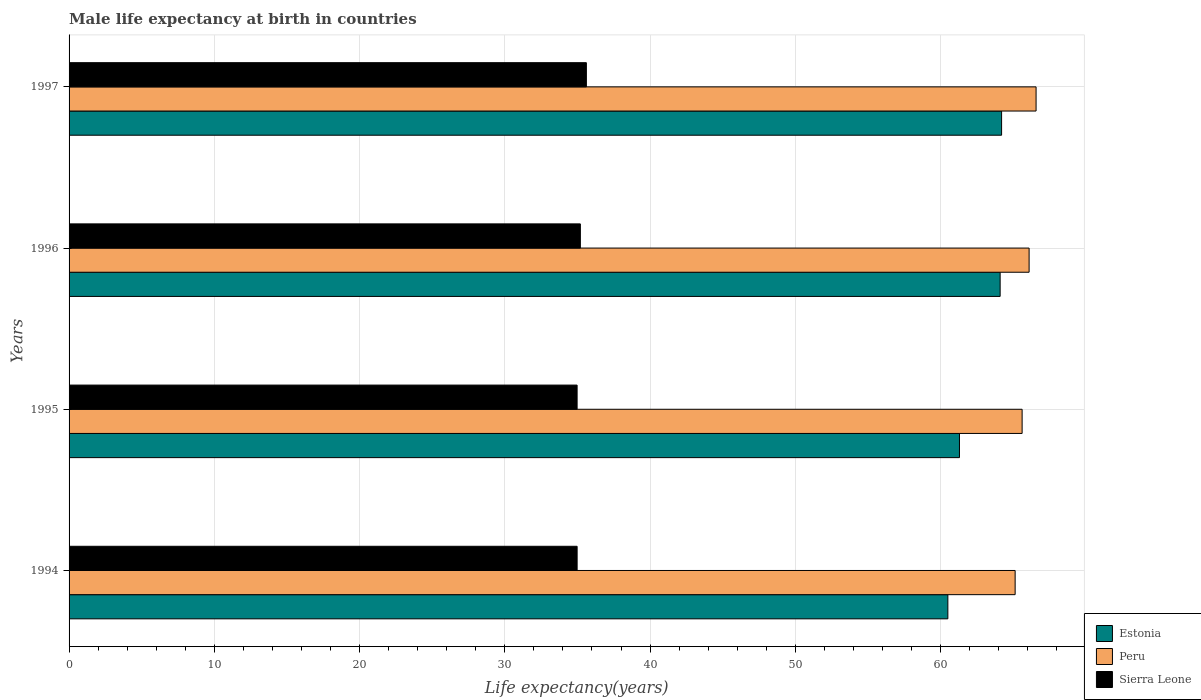How many groups of bars are there?
Your response must be concise. 4. How many bars are there on the 1st tick from the top?
Offer a very short reply. 3. How many bars are there on the 1st tick from the bottom?
Provide a succinct answer. 3. What is the label of the 4th group of bars from the top?
Your answer should be very brief. 1994. In how many cases, is the number of bars for a given year not equal to the number of legend labels?
Provide a succinct answer. 0. What is the male life expectancy at birth in Sierra Leone in 1995?
Your answer should be compact. 34.98. Across all years, what is the maximum male life expectancy at birth in Sierra Leone?
Provide a succinct answer. 35.61. Across all years, what is the minimum male life expectancy at birth in Sierra Leone?
Provide a succinct answer. 34.98. In which year was the male life expectancy at birth in Estonia minimum?
Keep it short and to the point. 1994. What is the total male life expectancy at birth in Sierra Leone in the graph?
Make the answer very short. 140.77. What is the difference between the male life expectancy at birth in Sierra Leone in 1994 and that in 1995?
Ensure brevity in your answer.  0. What is the difference between the male life expectancy at birth in Sierra Leone in 1994 and the male life expectancy at birth in Peru in 1997?
Offer a terse response. -31.6. What is the average male life expectancy at birth in Peru per year?
Make the answer very short. 65.85. In the year 1996, what is the difference between the male life expectancy at birth in Peru and male life expectancy at birth in Sierra Leone?
Your answer should be very brief. 30.89. In how many years, is the male life expectancy at birth in Estonia greater than 42 years?
Offer a terse response. 4. What is the ratio of the male life expectancy at birth in Estonia in 1994 to that in 1997?
Provide a succinct answer. 0.94. Is the male life expectancy at birth in Sierra Leone in 1995 less than that in 1997?
Provide a short and direct response. Yes. Is the difference between the male life expectancy at birth in Peru in 1996 and 1997 greater than the difference between the male life expectancy at birth in Sierra Leone in 1996 and 1997?
Make the answer very short. No. What is the difference between the highest and the second highest male life expectancy at birth in Sierra Leone?
Your response must be concise. 0.41. What is the difference between the highest and the lowest male life expectancy at birth in Estonia?
Give a very brief answer. 3.7. What does the 3rd bar from the top in 1996 represents?
Make the answer very short. Estonia. What does the 2nd bar from the bottom in 1996 represents?
Provide a succinct answer. Peru. Are all the bars in the graph horizontal?
Your answer should be very brief. Yes. What is the difference between two consecutive major ticks on the X-axis?
Give a very brief answer. 10. Does the graph contain any zero values?
Give a very brief answer. No. Where does the legend appear in the graph?
Ensure brevity in your answer.  Bottom right. How many legend labels are there?
Your response must be concise. 3. What is the title of the graph?
Your response must be concise. Male life expectancy at birth in countries. Does "Hungary" appear as one of the legend labels in the graph?
Offer a very short reply. No. What is the label or title of the X-axis?
Ensure brevity in your answer.  Life expectancy(years). What is the Life expectancy(years) in Estonia in 1994?
Your response must be concise. 60.5. What is the Life expectancy(years) in Peru in 1994?
Your answer should be compact. 65.13. What is the Life expectancy(years) in Sierra Leone in 1994?
Provide a succinct answer. 34.98. What is the Life expectancy(years) in Estonia in 1995?
Offer a very short reply. 61.3. What is the Life expectancy(years) in Peru in 1995?
Ensure brevity in your answer.  65.61. What is the Life expectancy(years) of Sierra Leone in 1995?
Your response must be concise. 34.98. What is the Life expectancy(years) of Estonia in 1996?
Keep it short and to the point. 64.1. What is the Life expectancy(years) of Peru in 1996?
Provide a succinct answer. 66.09. What is the Life expectancy(years) in Sierra Leone in 1996?
Provide a short and direct response. 35.2. What is the Life expectancy(years) in Estonia in 1997?
Ensure brevity in your answer.  64.2. What is the Life expectancy(years) of Peru in 1997?
Make the answer very short. 66.57. What is the Life expectancy(years) in Sierra Leone in 1997?
Your answer should be very brief. 35.61. Across all years, what is the maximum Life expectancy(years) in Estonia?
Your answer should be compact. 64.2. Across all years, what is the maximum Life expectancy(years) of Peru?
Offer a terse response. 66.57. Across all years, what is the maximum Life expectancy(years) in Sierra Leone?
Provide a short and direct response. 35.61. Across all years, what is the minimum Life expectancy(years) of Estonia?
Offer a very short reply. 60.5. Across all years, what is the minimum Life expectancy(years) in Peru?
Keep it short and to the point. 65.13. Across all years, what is the minimum Life expectancy(years) in Sierra Leone?
Your answer should be compact. 34.98. What is the total Life expectancy(years) of Estonia in the graph?
Provide a succinct answer. 250.1. What is the total Life expectancy(years) in Peru in the graph?
Your answer should be very brief. 263.41. What is the total Life expectancy(years) of Sierra Leone in the graph?
Make the answer very short. 140.77. What is the difference between the Life expectancy(years) of Peru in 1994 and that in 1995?
Give a very brief answer. -0.48. What is the difference between the Life expectancy(years) in Estonia in 1994 and that in 1996?
Offer a terse response. -3.6. What is the difference between the Life expectancy(years) in Peru in 1994 and that in 1996?
Offer a very short reply. -0.96. What is the difference between the Life expectancy(years) of Sierra Leone in 1994 and that in 1996?
Keep it short and to the point. -0.22. What is the difference between the Life expectancy(years) in Peru in 1994 and that in 1997?
Provide a succinct answer. -1.44. What is the difference between the Life expectancy(years) in Sierra Leone in 1994 and that in 1997?
Give a very brief answer. -0.64. What is the difference between the Life expectancy(years) in Peru in 1995 and that in 1996?
Give a very brief answer. -0.48. What is the difference between the Life expectancy(years) in Sierra Leone in 1995 and that in 1996?
Offer a very short reply. -0.22. What is the difference between the Life expectancy(years) in Estonia in 1995 and that in 1997?
Provide a short and direct response. -2.9. What is the difference between the Life expectancy(years) of Peru in 1995 and that in 1997?
Your answer should be very brief. -0.96. What is the difference between the Life expectancy(years) of Sierra Leone in 1995 and that in 1997?
Make the answer very short. -0.64. What is the difference between the Life expectancy(years) of Estonia in 1996 and that in 1997?
Offer a terse response. -0.1. What is the difference between the Life expectancy(years) of Peru in 1996 and that in 1997?
Give a very brief answer. -0.48. What is the difference between the Life expectancy(years) of Sierra Leone in 1996 and that in 1997?
Make the answer very short. -0.41. What is the difference between the Life expectancy(years) of Estonia in 1994 and the Life expectancy(years) of Peru in 1995?
Provide a succinct answer. -5.11. What is the difference between the Life expectancy(years) of Estonia in 1994 and the Life expectancy(years) of Sierra Leone in 1995?
Your answer should be very brief. 25.52. What is the difference between the Life expectancy(years) of Peru in 1994 and the Life expectancy(years) of Sierra Leone in 1995?
Offer a very short reply. 30.16. What is the difference between the Life expectancy(years) in Estonia in 1994 and the Life expectancy(years) in Peru in 1996?
Your answer should be compact. -5.59. What is the difference between the Life expectancy(years) of Estonia in 1994 and the Life expectancy(years) of Sierra Leone in 1996?
Keep it short and to the point. 25.3. What is the difference between the Life expectancy(years) of Peru in 1994 and the Life expectancy(years) of Sierra Leone in 1996?
Keep it short and to the point. 29.93. What is the difference between the Life expectancy(years) of Estonia in 1994 and the Life expectancy(years) of Peru in 1997?
Ensure brevity in your answer.  -6.07. What is the difference between the Life expectancy(years) in Estonia in 1994 and the Life expectancy(years) in Sierra Leone in 1997?
Your response must be concise. 24.89. What is the difference between the Life expectancy(years) of Peru in 1994 and the Life expectancy(years) of Sierra Leone in 1997?
Offer a terse response. 29.52. What is the difference between the Life expectancy(years) in Estonia in 1995 and the Life expectancy(years) in Peru in 1996?
Offer a terse response. -4.79. What is the difference between the Life expectancy(years) of Estonia in 1995 and the Life expectancy(years) of Sierra Leone in 1996?
Provide a short and direct response. 26.1. What is the difference between the Life expectancy(years) of Peru in 1995 and the Life expectancy(years) of Sierra Leone in 1996?
Offer a terse response. 30.41. What is the difference between the Life expectancy(years) of Estonia in 1995 and the Life expectancy(years) of Peru in 1997?
Give a very brief answer. -5.27. What is the difference between the Life expectancy(years) of Estonia in 1995 and the Life expectancy(years) of Sierra Leone in 1997?
Keep it short and to the point. 25.69. What is the difference between the Life expectancy(years) of Peru in 1995 and the Life expectancy(years) of Sierra Leone in 1997?
Offer a very short reply. 30. What is the difference between the Life expectancy(years) of Estonia in 1996 and the Life expectancy(years) of Peru in 1997?
Offer a terse response. -2.47. What is the difference between the Life expectancy(years) of Estonia in 1996 and the Life expectancy(years) of Sierra Leone in 1997?
Provide a short and direct response. 28.49. What is the difference between the Life expectancy(years) in Peru in 1996 and the Life expectancy(years) in Sierra Leone in 1997?
Make the answer very short. 30.48. What is the average Life expectancy(years) of Estonia per year?
Ensure brevity in your answer.  62.52. What is the average Life expectancy(years) in Peru per year?
Offer a very short reply. 65.85. What is the average Life expectancy(years) of Sierra Leone per year?
Offer a very short reply. 35.19. In the year 1994, what is the difference between the Life expectancy(years) of Estonia and Life expectancy(years) of Peru?
Your answer should be compact. -4.63. In the year 1994, what is the difference between the Life expectancy(years) of Estonia and Life expectancy(years) of Sierra Leone?
Give a very brief answer. 25.52. In the year 1994, what is the difference between the Life expectancy(years) of Peru and Life expectancy(years) of Sierra Leone?
Keep it short and to the point. 30.16. In the year 1995, what is the difference between the Life expectancy(years) of Estonia and Life expectancy(years) of Peru?
Keep it short and to the point. -4.31. In the year 1995, what is the difference between the Life expectancy(years) of Estonia and Life expectancy(years) of Sierra Leone?
Your answer should be very brief. 26.32. In the year 1995, what is the difference between the Life expectancy(years) in Peru and Life expectancy(years) in Sierra Leone?
Provide a succinct answer. 30.64. In the year 1996, what is the difference between the Life expectancy(years) of Estonia and Life expectancy(years) of Peru?
Provide a succinct answer. -1.99. In the year 1996, what is the difference between the Life expectancy(years) in Estonia and Life expectancy(years) in Sierra Leone?
Give a very brief answer. 28.9. In the year 1996, what is the difference between the Life expectancy(years) in Peru and Life expectancy(years) in Sierra Leone?
Your response must be concise. 30.89. In the year 1997, what is the difference between the Life expectancy(years) in Estonia and Life expectancy(years) in Peru?
Your answer should be compact. -2.37. In the year 1997, what is the difference between the Life expectancy(years) of Estonia and Life expectancy(years) of Sierra Leone?
Your response must be concise. 28.59. In the year 1997, what is the difference between the Life expectancy(years) in Peru and Life expectancy(years) in Sierra Leone?
Offer a terse response. 30.96. What is the ratio of the Life expectancy(years) in Estonia in 1994 to that in 1995?
Offer a very short reply. 0.99. What is the ratio of the Life expectancy(years) in Peru in 1994 to that in 1995?
Provide a short and direct response. 0.99. What is the ratio of the Life expectancy(years) in Sierra Leone in 1994 to that in 1995?
Offer a very short reply. 1. What is the ratio of the Life expectancy(years) of Estonia in 1994 to that in 1996?
Give a very brief answer. 0.94. What is the ratio of the Life expectancy(years) in Peru in 1994 to that in 1996?
Ensure brevity in your answer.  0.99. What is the ratio of the Life expectancy(years) of Sierra Leone in 1994 to that in 1996?
Your response must be concise. 0.99. What is the ratio of the Life expectancy(years) in Estonia in 1994 to that in 1997?
Provide a succinct answer. 0.94. What is the ratio of the Life expectancy(years) in Peru in 1994 to that in 1997?
Your answer should be very brief. 0.98. What is the ratio of the Life expectancy(years) in Sierra Leone in 1994 to that in 1997?
Make the answer very short. 0.98. What is the ratio of the Life expectancy(years) of Estonia in 1995 to that in 1996?
Make the answer very short. 0.96. What is the ratio of the Life expectancy(years) in Sierra Leone in 1995 to that in 1996?
Make the answer very short. 0.99. What is the ratio of the Life expectancy(years) of Estonia in 1995 to that in 1997?
Your answer should be compact. 0.95. What is the ratio of the Life expectancy(years) in Peru in 1995 to that in 1997?
Provide a succinct answer. 0.99. What is the ratio of the Life expectancy(years) of Sierra Leone in 1995 to that in 1997?
Ensure brevity in your answer.  0.98. What is the ratio of the Life expectancy(years) of Peru in 1996 to that in 1997?
Keep it short and to the point. 0.99. What is the ratio of the Life expectancy(years) of Sierra Leone in 1996 to that in 1997?
Provide a short and direct response. 0.99. What is the difference between the highest and the second highest Life expectancy(years) of Peru?
Make the answer very short. 0.48. What is the difference between the highest and the second highest Life expectancy(years) of Sierra Leone?
Offer a terse response. 0.41. What is the difference between the highest and the lowest Life expectancy(years) of Peru?
Give a very brief answer. 1.44. What is the difference between the highest and the lowest Life expectancy(years) of Sierra Leone?
Your response must be concise. 0.64. 